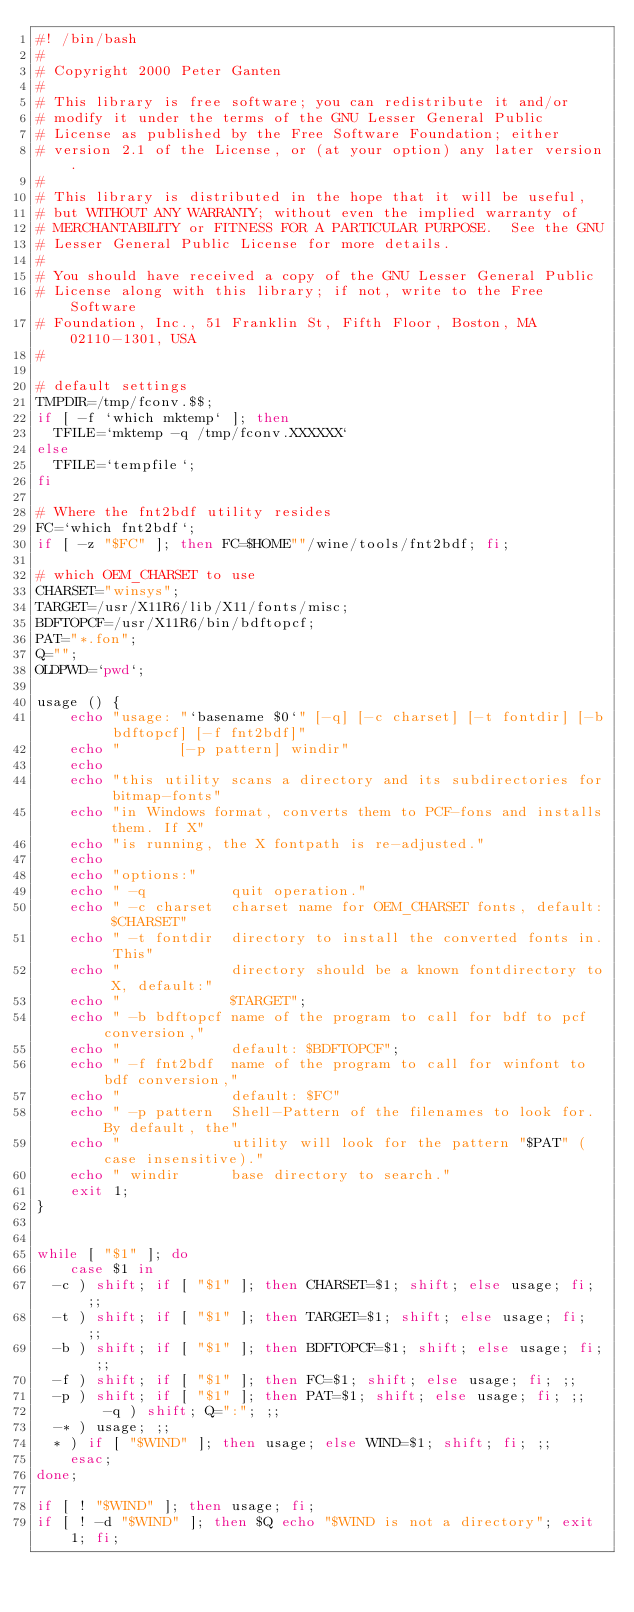<code> <loc_0><loc_0><loc_500><loc_500><_Bash_>#! /bin/bash
#
# Copyright 2000 Peter Ganten
#
# This library is free software; you can redistribute it and/or
# modify it under the terms of the GNU Lesser General Public
# License as published by the Free Software Foundation; either
# version 2.1 of the License, or (at your option) any later version.
#
# This library is distributed in the hope that it will be useful,
# but WITHOUT ANY WARRANTY; without even the implied warranty of
# MERCHANTABILITY or FITNESS FOR A PARTICULAR PURPOSE.  See the GNU
# Lesser General Public License for more details.
#
# You should have received a copy of the GNU Lesser General Public
# License along with this library; if not, write to the Free Software
# Foundation, Inc., 51 Franklin St, Fifth Floor, Boston, MA 02110-1301, USA
#

# default settings
TMPDIR=/tmp/fconv.$$;
if [ -f `which mktemp` ]; then
  TFILE=`mktemp -q /tmp/fconv.XXXXXX`
else
  TFILE=`tempfile`;
fi

# Where the fnt2bdf utility resides
FC=`which fnt2bdf`;
if [ -z "$FC" ]; then FC=$HOME""/wine/tools/fnt2bdf; fi;

# which OEM_CHARSET to use
CHARSET="winsys";
TARGET=/usr/X11R6/lib/X11/fonts/misc;
BDFTOPCF=/usr/X11R6/bin/bdftopcf;
PAT="*.fon";
Q="";
OLDPWD=`pwd`;

usage () {
    echo "usage: "`basename $0`" [-q] [-c charset] [-t fontdir] [-b bdftopcf] [-f fnt2bdf]"
    echo "       [-p pattern] windir"
    echo
    echo "this utility scans a directory and its subdirectories for bitmap-fonts"
    echo "in Windows format, converts them to PCF-fons and installs them. If X"
    echo "is running, the X fontpath is re-adjusted."
    echo
    echo "options:"
    echo " -q          quit operation."
    echo " -c charset  charset name for OEM_CHARSET fonts, default: $CHARSET"
    echo " -t fontdir  directory to install the converted fonts in. This"
    echo "             directory should be a known fontdirectory to X, default:"
    echo "             $TARGET";
    echo " -b bdftopcf name of the program to call for bdf to pcf conversion,"
    echo "             default: $BDFTOPCF";
    echo " -f fnt2bdf  name of the program to call for winfont to bdf conversion,"
    echo "             default: $FC"
    echo " -p pattern  Shell-Pattern of the filenames to look for. By default, the"
    echo "             utility will look for the pattern "$PAT" (case insensitive)."
    echo " windir      base directory to search."
    exit 1;
}


while [ "$1" ]; do
    case $1 in
	-c ) shift; if [ "$1" ]; then CHARSET=$1; shift; else usage; fi; ;;
	-t ) shift; if [ "$1" ]; then TARGET=$1; shift; else usage; fi; ;;
	-b ) shift; if [ "$1" ]; then BDFTOPCF=$1; shift; else usage; fi; ;;
	-f ) shift; if [ "$1" ]; then FC=$1; shift; else usage; fi; ;;
	-p ) shift; if [ "$1" ]; then PAT=$1; shift; else usage; fi; ;;
        -q ) shift; Q=":"; ;;
	-* ) usage; ;;
	* ) if [ "$WIND" ]; then usage; else WIND=$1; shift; fi; ;;
    esac;
done;

if [ ! "$WIND" ]; then usage; fi;
if [ ! -d "$WIND" ]; then $Q echo "$WIND is not a directory"; exit 1; fi;</code> 